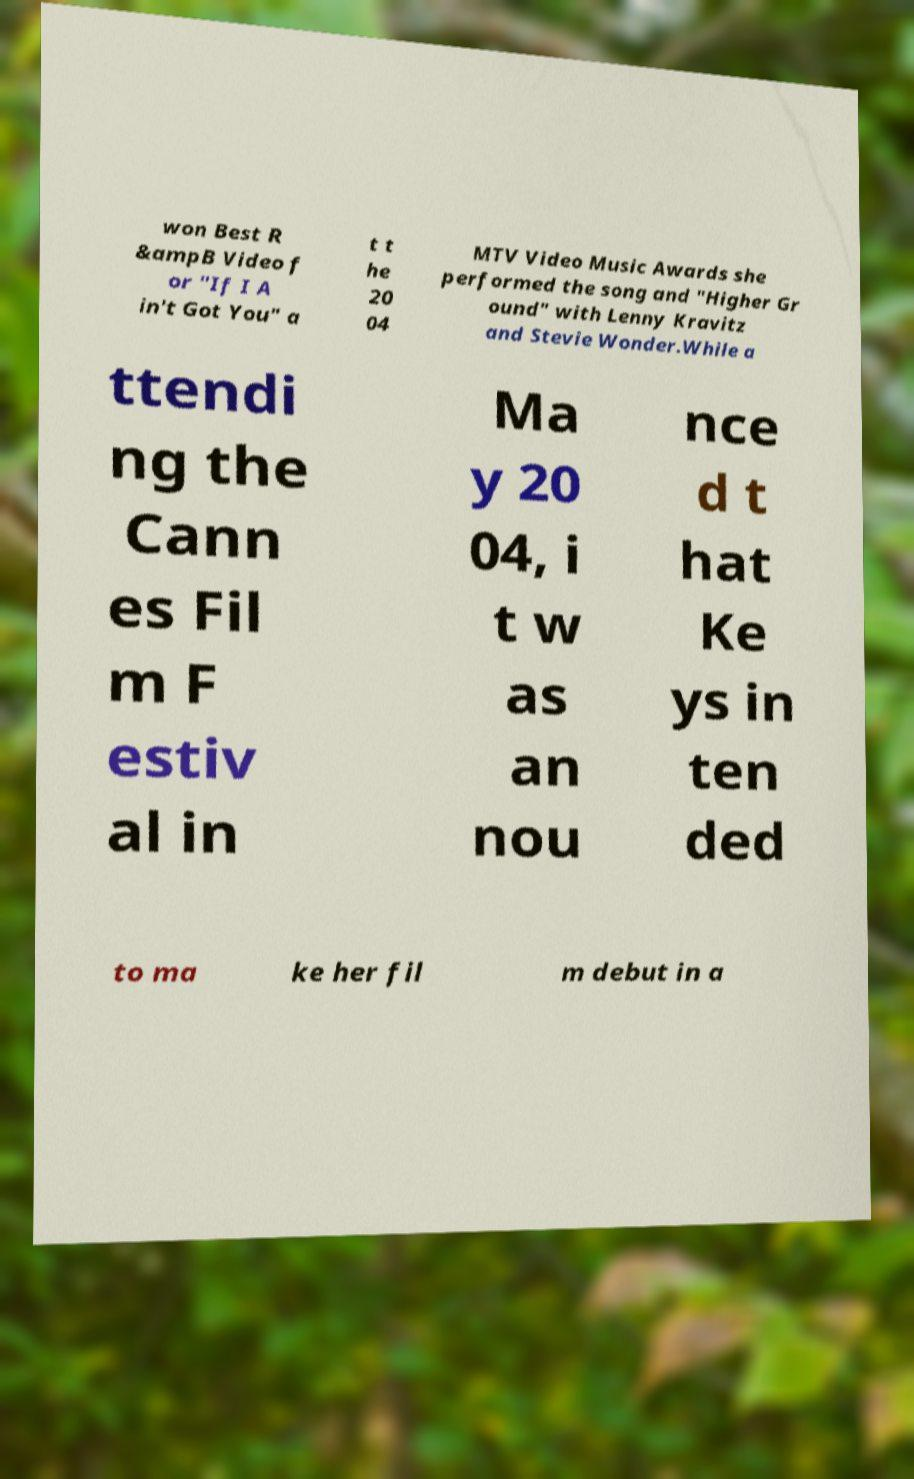Could you assist in decoding the text presented in this image and type it out clearly? won Best R &ampB Video f or "If I A in't Got You" a t t he 20 04 MTV Video Music Awards she performed the song and "Higher Gr ound" with Lenny Kravitz and Stevie Wonder.While a ttendi ng the Cann es Fil m F estiv al in Ma y 20 04, i t w as an nou nce d t hat Ke ys in ten ded to ma ke her fil m debut in a 